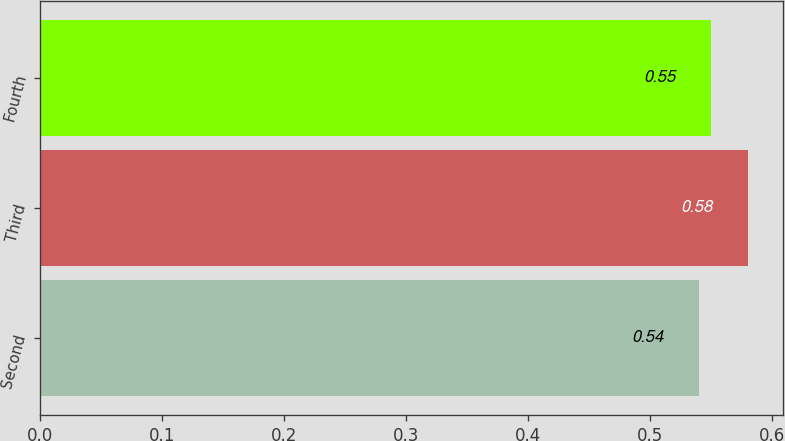Convert chart. <chart><loc_0><loc_0><loc_500><loc_500><bar_chart><fcel>Second<fcel>Third<fcel>Fourth<nl><fcel>0.54<fcel>0.58<fcel>0.55<nl></chart> 